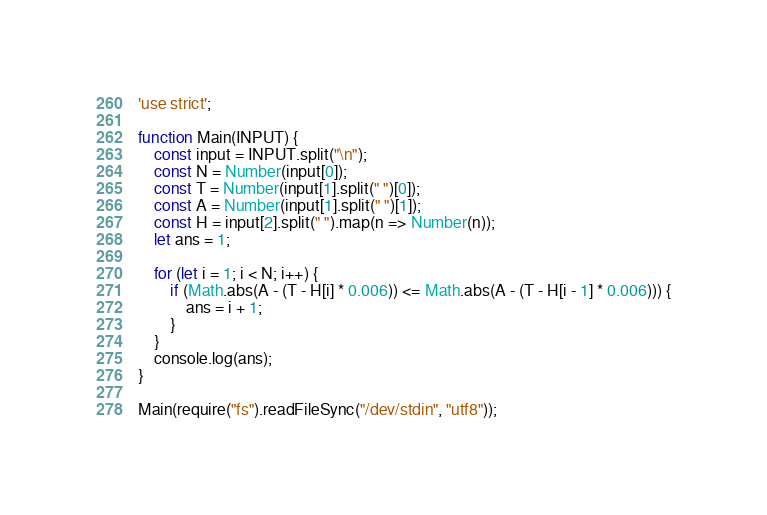<code> <loc_0><loc_0><loc_500><loc_500><_JavaScript_>'use strict';

function Main(INPUT) {
    const input = INPUT.split("\n");
    const N = Number(input[0]);
    const T = Number(input[1].split(" ")[0]);
    const A = Number(input[1].split(" ")[1]);
    const H = input[2].split(" ").map(n => Number(n));
    let ans = 1;

    for (let i = 1; i < N; i++) {
        if (Math.abs(A - (T - H[i] * 0.006)) <= Math.abs(A - (T - H[i - 1] * 0.006))) {
            ans = i + 1;
        }
    }
    console.log(ans);
}

Main(require("fs").readFileSync("/dev/stdin", "utf8"));
</code> 